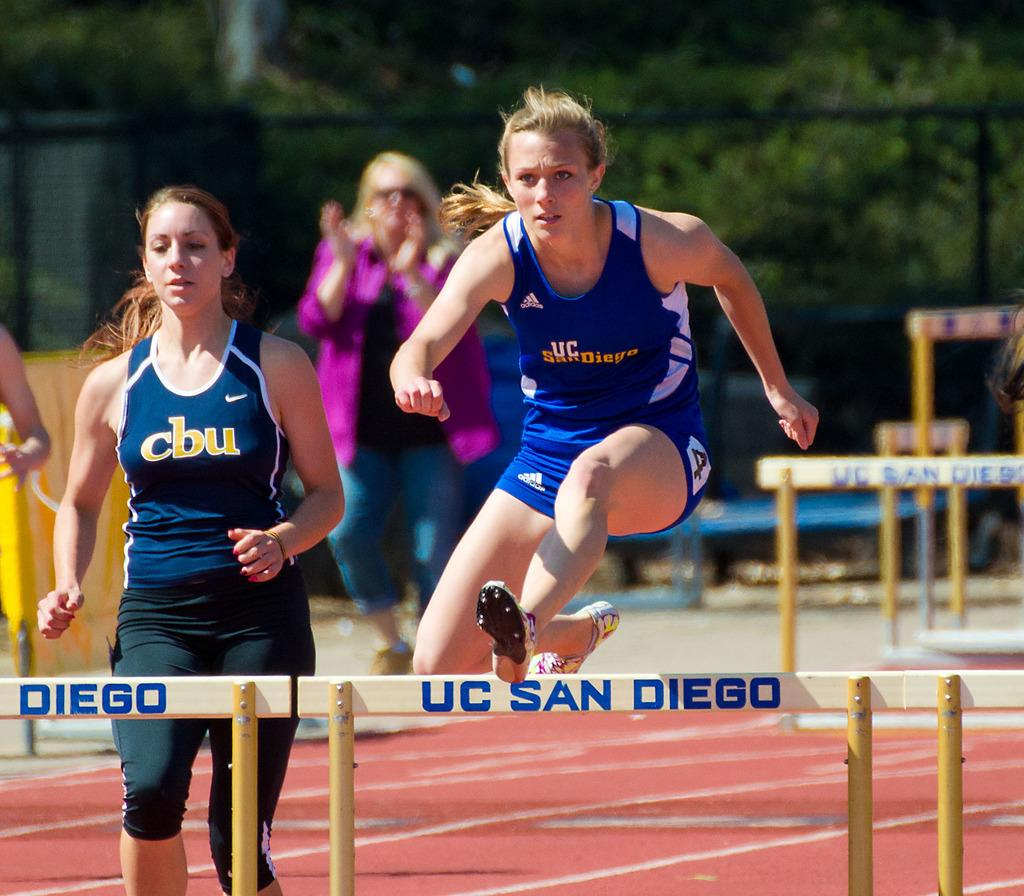<image>
Write a terse but informative summary of the picture. Hurdles have the school name UC San Diego on them. 